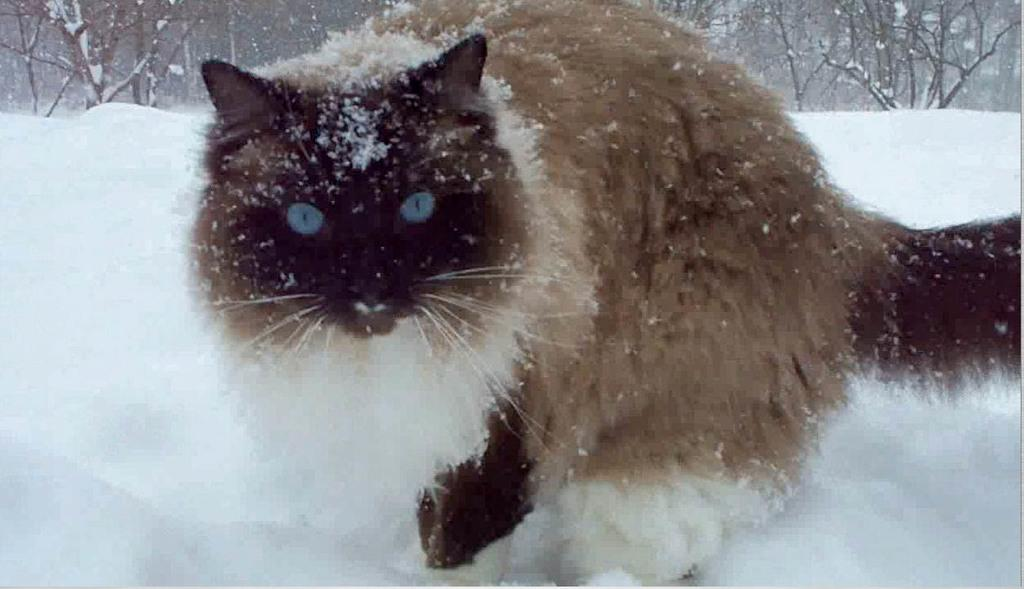What is the main subject in the foreground of the picture? There is a cat in the foreground of the picture. What is the condition of the ground in the foreground of the picture? There is snow in the foreground of the picture. What can be seen in the background of the picture? There are trees in the background of the picture. What type of creature can be seen using its tongue to catch snowflakes in the image? There is no creature using its tongue to catch snowflakes in the image; it only features a cat in the foreground. 